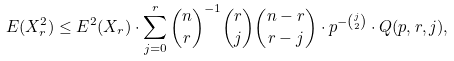Convert formula to latex. <formula><loc_0><loc_0><loc_500><loc_500>E ( X _ { r } ^ { 2 } ) \leq E ^ { 2 } ( X _ { r } ) \cdot \sum _ { j = 0 } ^ { r } { n \choose r } ^ { - 1 } { r \choose j } { n - r \choose r - j } \cdot p ^ { - { j \choose 2 } } \cdot Q ( p , r , j ) ,</formula> 